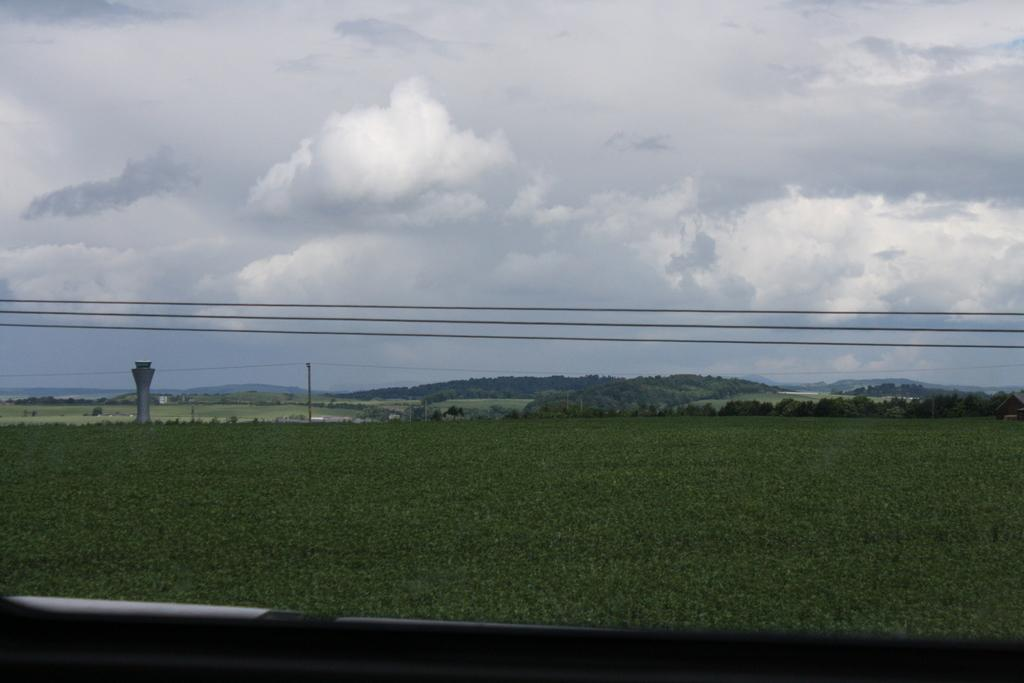What is the main feature in the foreground of the picture? There is a field in the foreground of the picture. What can be seen in the center of the picture? There are trees, a tower, poles, and cables in the center of the picture. What is the condition of the sky in the picture? The sky is cloudy in the picture. What is present at the bottom of the picture? There is railing at the bottom of the picture. How many people are in the crowd gathered around the gate in the image? There is no crowd or gate present in the image. What is the condition of the gate in the image? There is no gate present in the image, so it is not possible to determine its condition. 